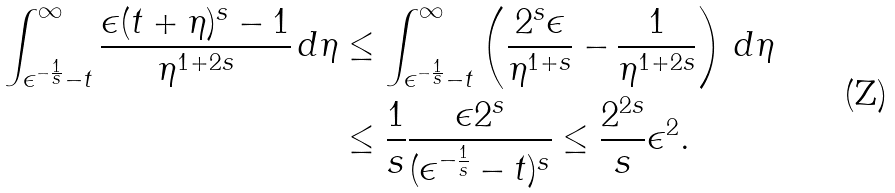<formula> <loc_0><loc_0><loc_500><loc_500>\int _ { \epsilon ^ { - \frac { 1 } { s } } - t } ^ { \infty } \frac { \epsilon ( t + \eta ) ^ { s } - 1 } { \eta ^ { 1 + 2 s } } \, d \eta & \leq \int _ { \epsilon ^ { - \frac { 1 } { s } } - t } ^ { \infty } \left ( \frac { 2 ^ { s } \epsilon } { \eta ^ { 1 + s } } - \frac { 1 } { \eta ^ { 1 + 2 s } } \right ) \, d \eta \\ & \leq \frac { 1 } { s } \frac { \epsilon 2 ^ { s } } { ( \epsilon ^ { - \frac { 1 } { s } } - t ) ^ { s } } \leq \frac { 2 ^ { 2 s } } { s } \epsilon ^ { 2 } .</formula> 